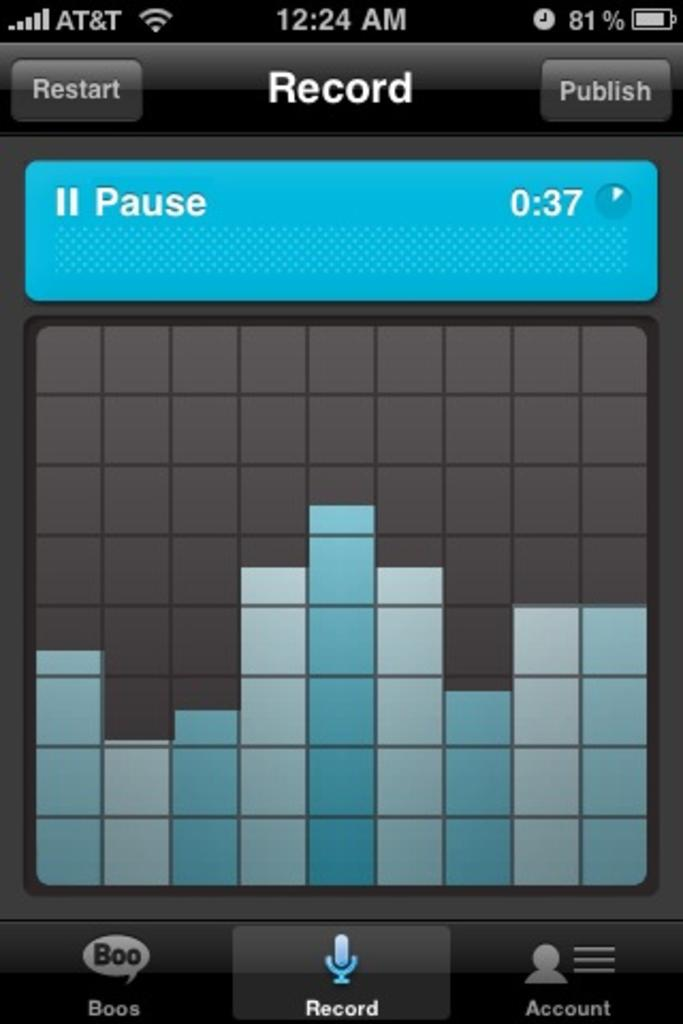<image>
Summarize the visual content of the image. A screen shot of a phone that is connected to AT&T. 